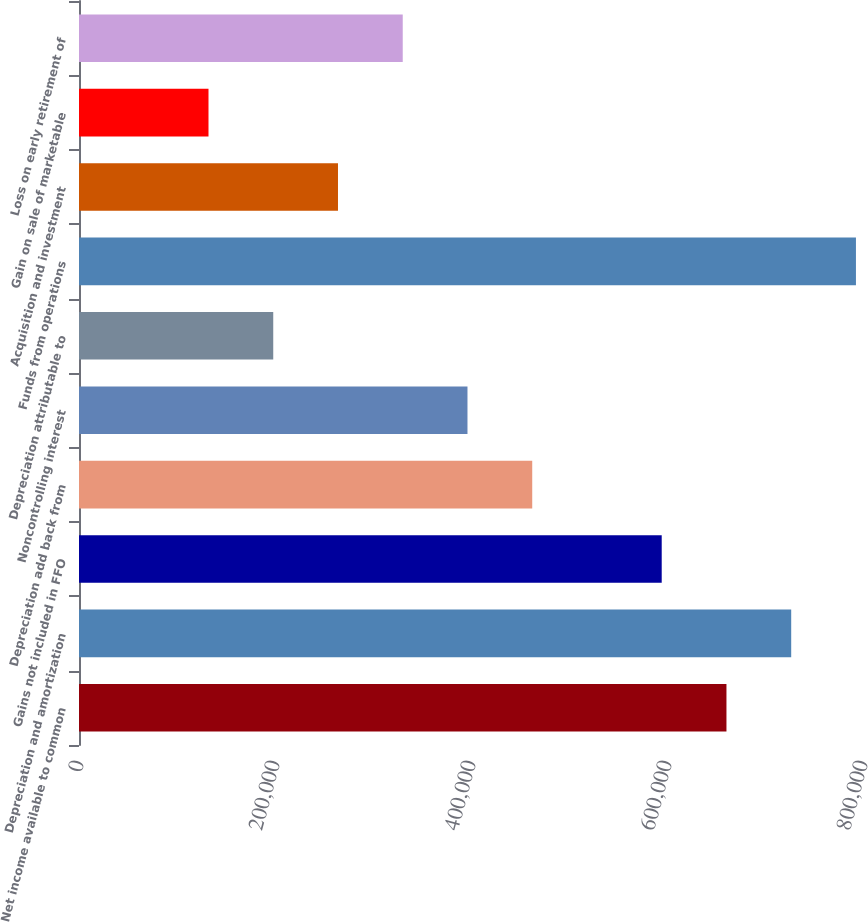Convert chart. <chart><loc_0><loc_0><loc_500><loc_500><bar_chart><fcel>Net income available to common<fcel>Depreciation and amortization<fcel>Gains not included in FFO<fcel>Depreciation add back from<fcel>Noncontrolling interest<fcel>Depreciation attributable to<fcel>Funds from operations<fcel>Acquisition and investment<fcel>Gain on sale of marketable<fcel>Loss on early retirement of<nl><fcel>660671<fcel>726737<fcel>594605<fcel>462473<fcel>396406<fcel>198208<fcel>792803<fcel>264274<fcel>132142<fcel>330340<nl></chart> 